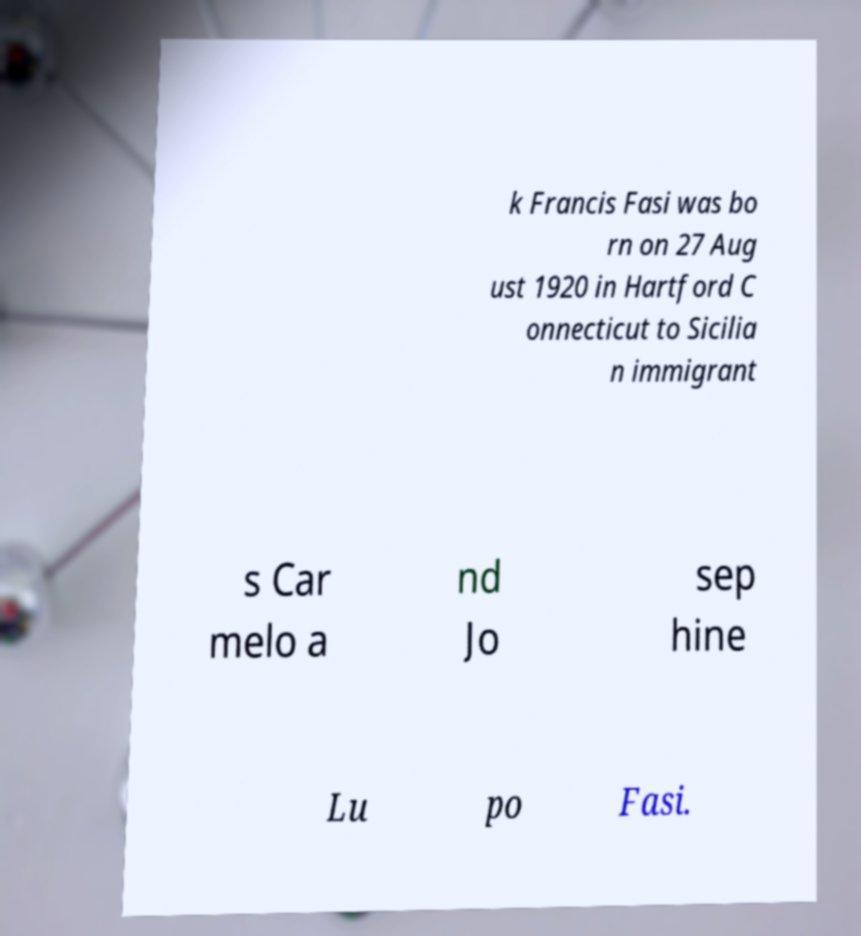There's text embedded in this image that I need extracted. Can you transcribe it verbatim? k Francis Fasi was bo rn on 27 Aug ust 1920 in Hartford C onnecticut to Sicilia n immigrant s Car melo a nd Jo sep hine Lu po Fasi. 